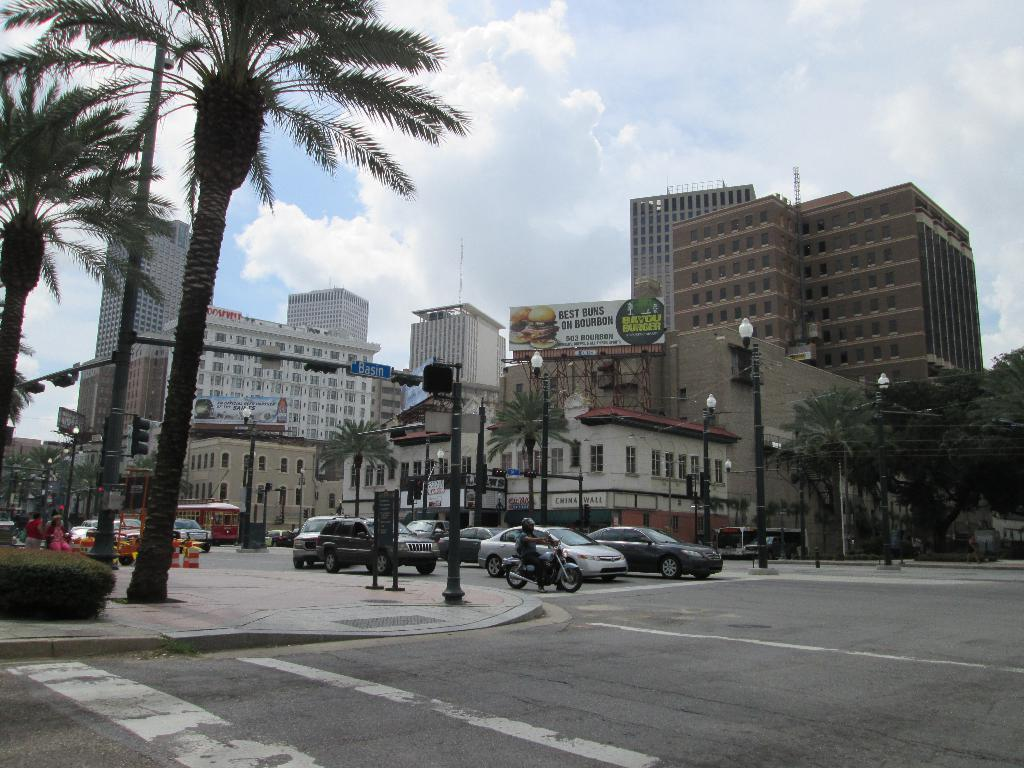What can be seen on the road in the image? There are vehicles on the road in the image. What type of natural elements are present in the image? There are trees and plants in the image. What type of artificial lighting is visible in the image? There are lights in the image. What is attached to a pole in the image? There is a board on a pole in the image. What can be seen in the background of the image? There are buildings, a hoarding, and the sky visible in the background. What type of popcorn is being sold on the hoarding in the image? There is no popcorn present in the image, nor is it being sold on the hoarding. What type of hat is the person wearing in the image? There are no people or hats visible in the image. 